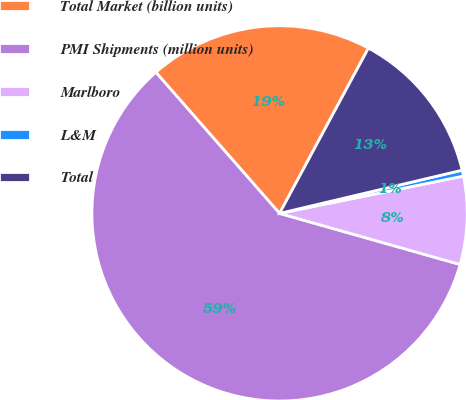<chart> <loc_0><loc_0><loc_500><loc_500><pie_chart><fcel>Total Market (billion units)<fcel>PMI Shipments (million units)<fcel>Marlboro<fcel>L&M<fcel>Total<nl><fcel>19.31%<fcel>59.15%<fcel>7.58%<fcel>0.51%<fcel>13.45%<nl></chart> 